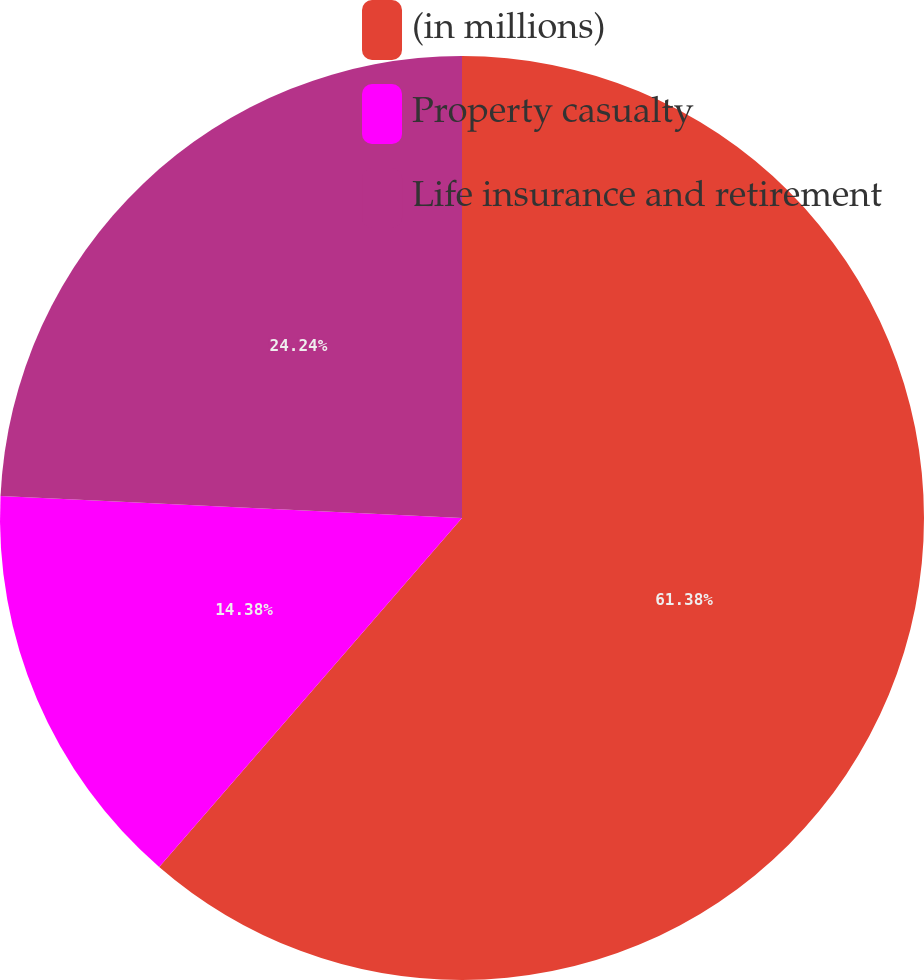Convert chart. <chart><loc_0><loc_0><loc_500><loc_500><pie_chart><fcel>(in millions)<fcel>Property casualty<fcel>Life insurance and retirement<nl><fcel>61.37%<fcel>14.38%<fcel>24.24%<nl></chart> 